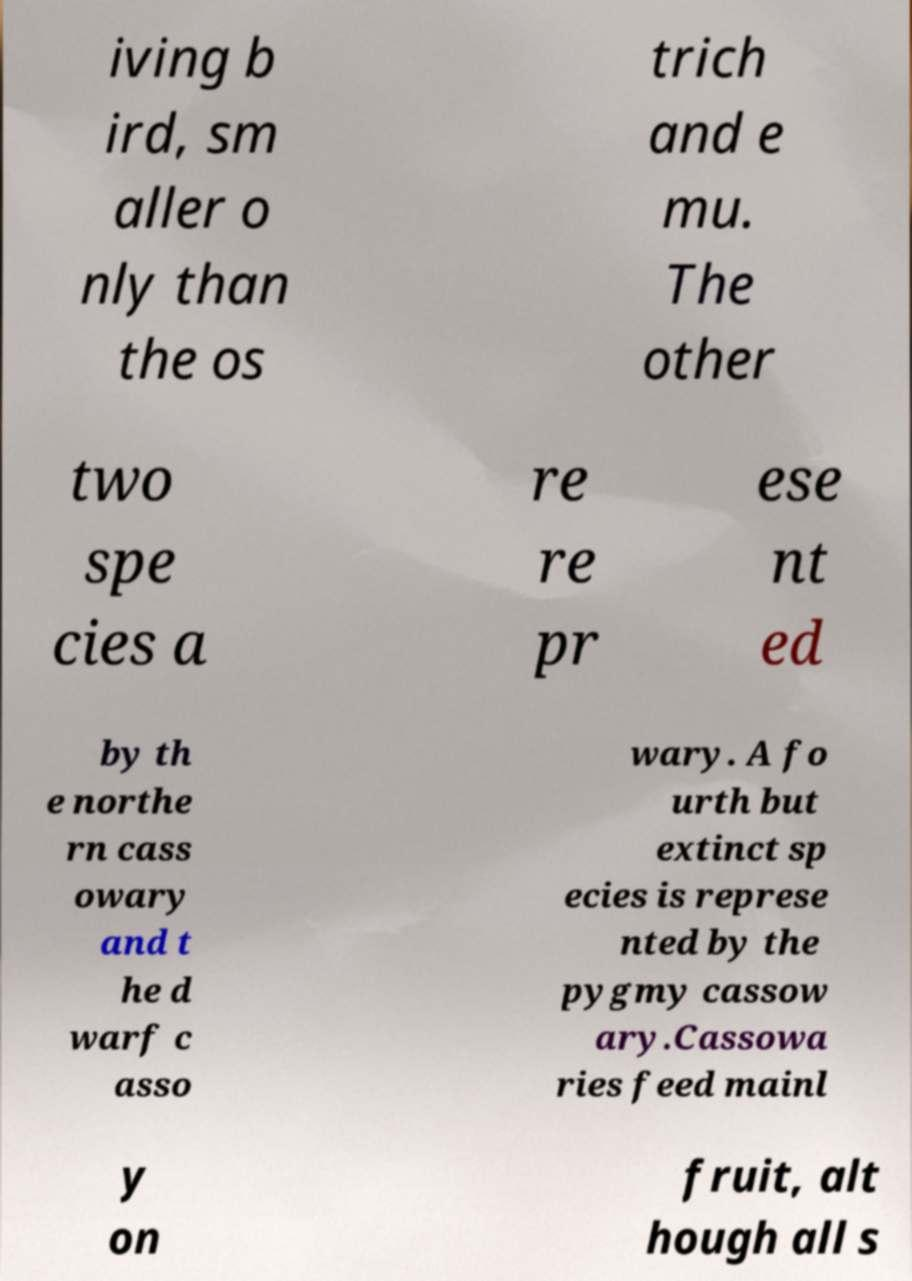Can you accurately transcribe the text from the provided image for me? iving b ird, sm aller o nly than the os trich and e mu. The other two spe cies a re re pr ese nt ed by th e northe rn cass owary and t he d warf c asso wary. A fo urth but extinct sp ecies is represe nted by the pygmy cassow ary.Cassowa ries feed mainl y on fruit, alt hough all s 